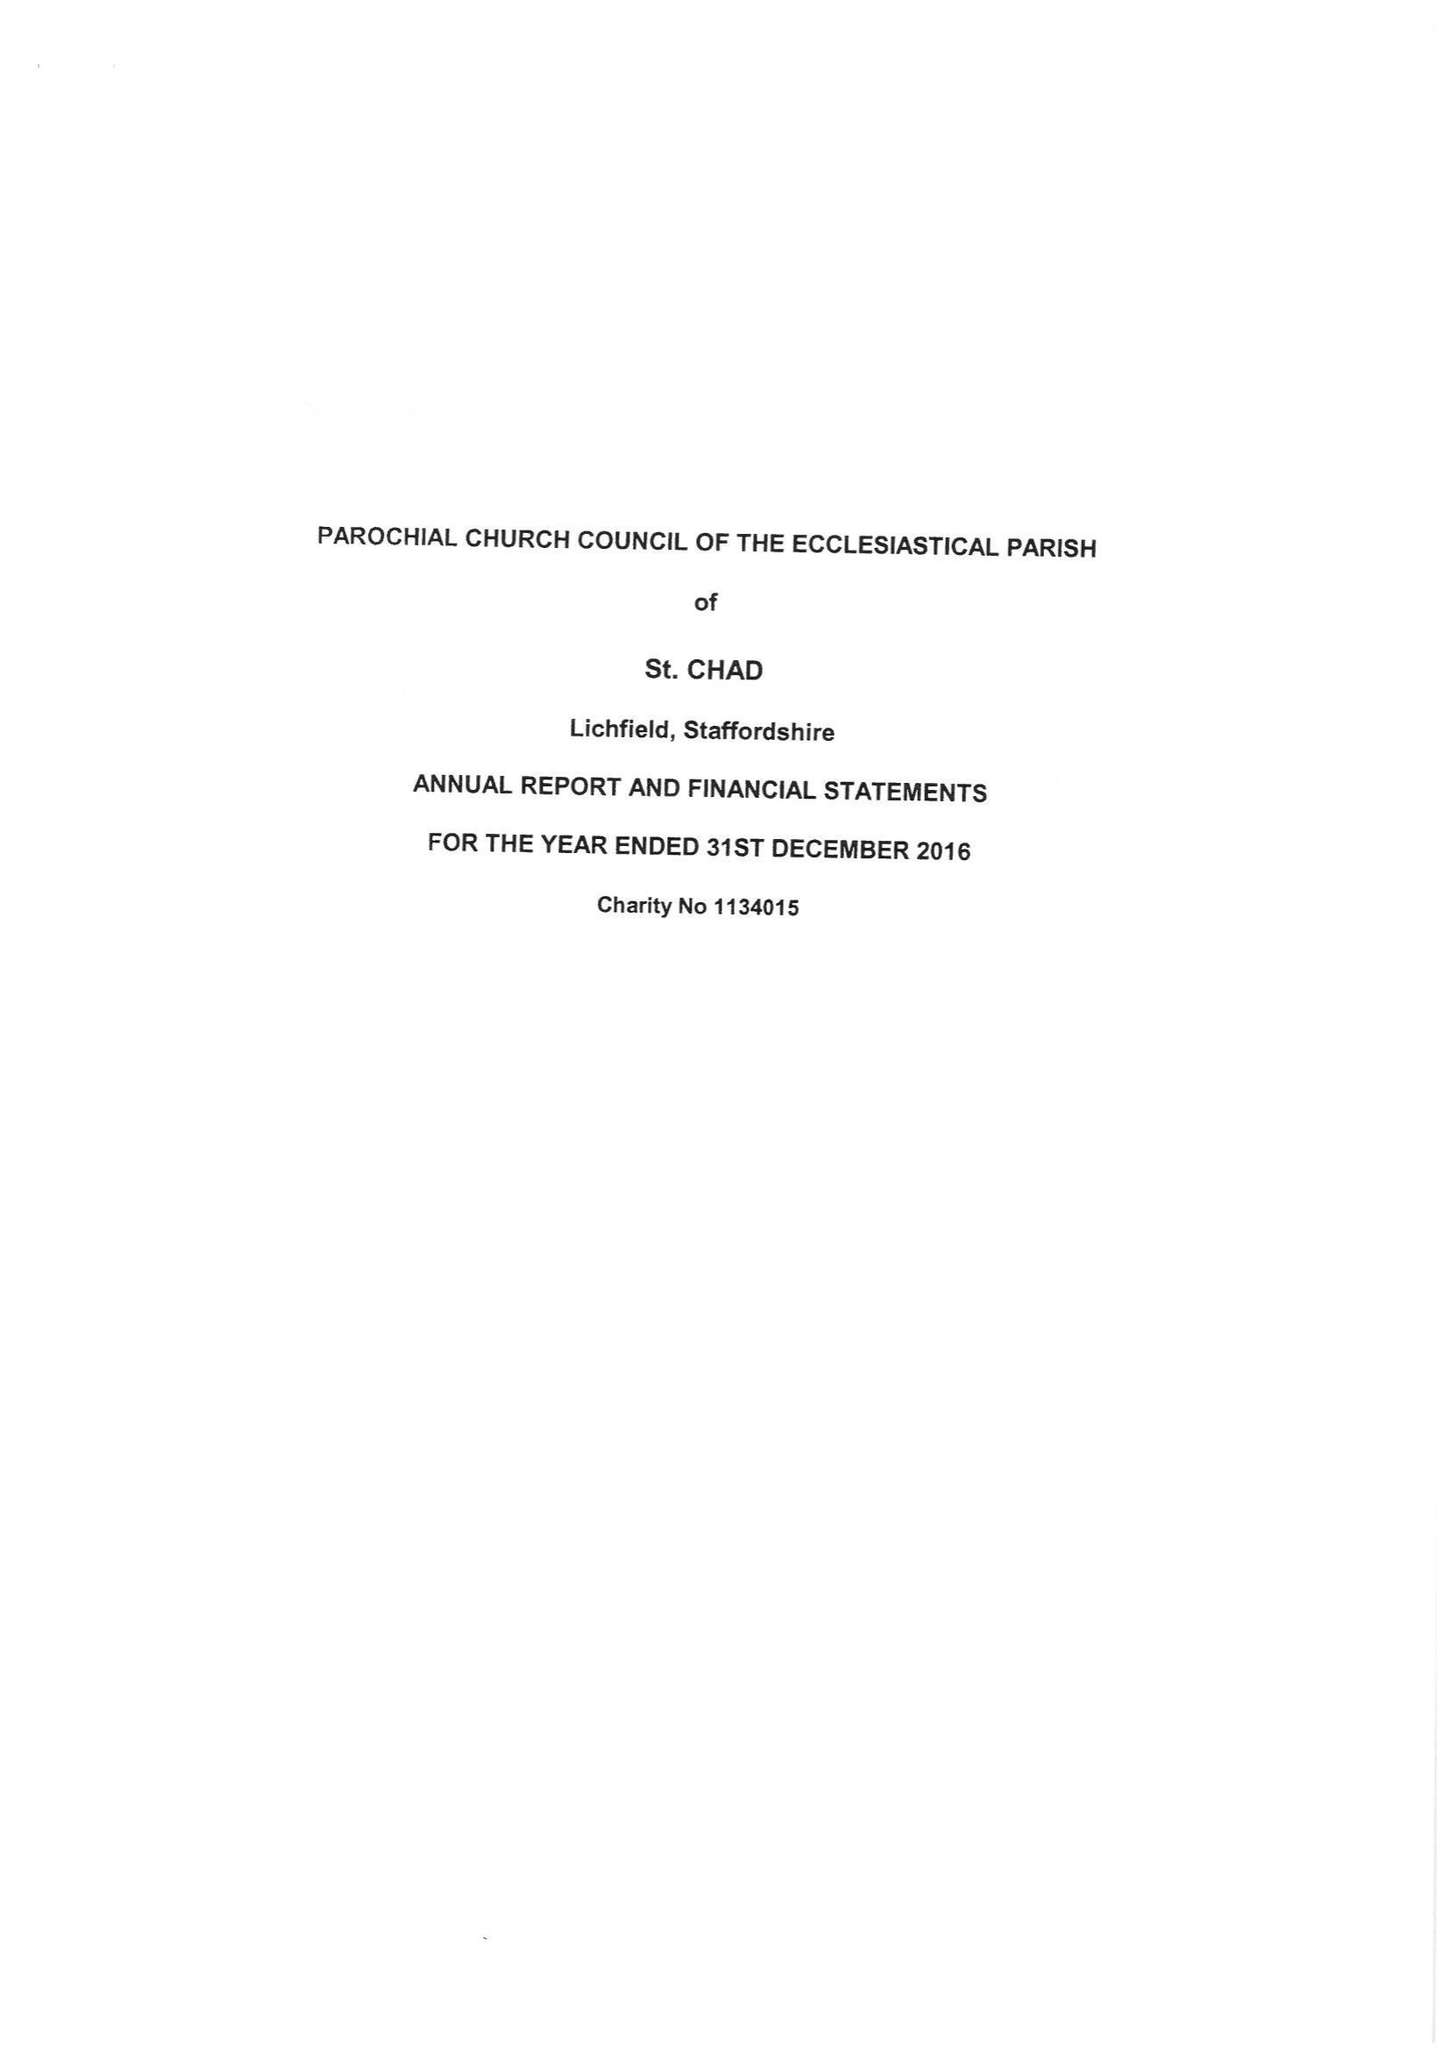What is the value for the income_annually_in_british_pounds?
Answer the question using a single word or phrase. 185494.00 